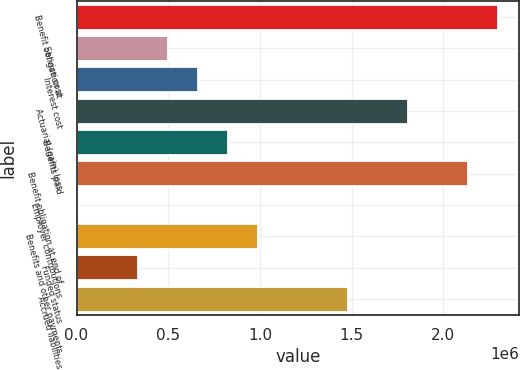Convert chart to OTSL. <chart><loc_0><loc_0><loc_500><loc_500><bar_chart><fcel>Benefit obligation at<fcel>Service cost<fcel>Interest cost<fcel>Actuarial (gain) loss<fcel>Benefits paid<fcel>Benefit obligation at end of<fcel>Employer contributions<fcel>Benefits and other payments<fcel>Funded status<fcel>Accrued liabilities<nl><fcel>2.29927e+06<fcel>498831<fcel>662507<fcel>1.80824e+06<fcel>826184<fcel>2.1356e+06<fcel>7801<fcel>989861<fcel>335154<fcel>1.48089e+06<nl></chart> 